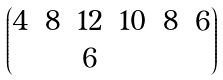<formula> <loc_0><loc_0><loc_500><loc_500>\begin{pmatrix} 4 & 8 & 1 2 & 1 0 & 8 & 6 \\ & & 6 & & & \end{pmatrix}</formula> 